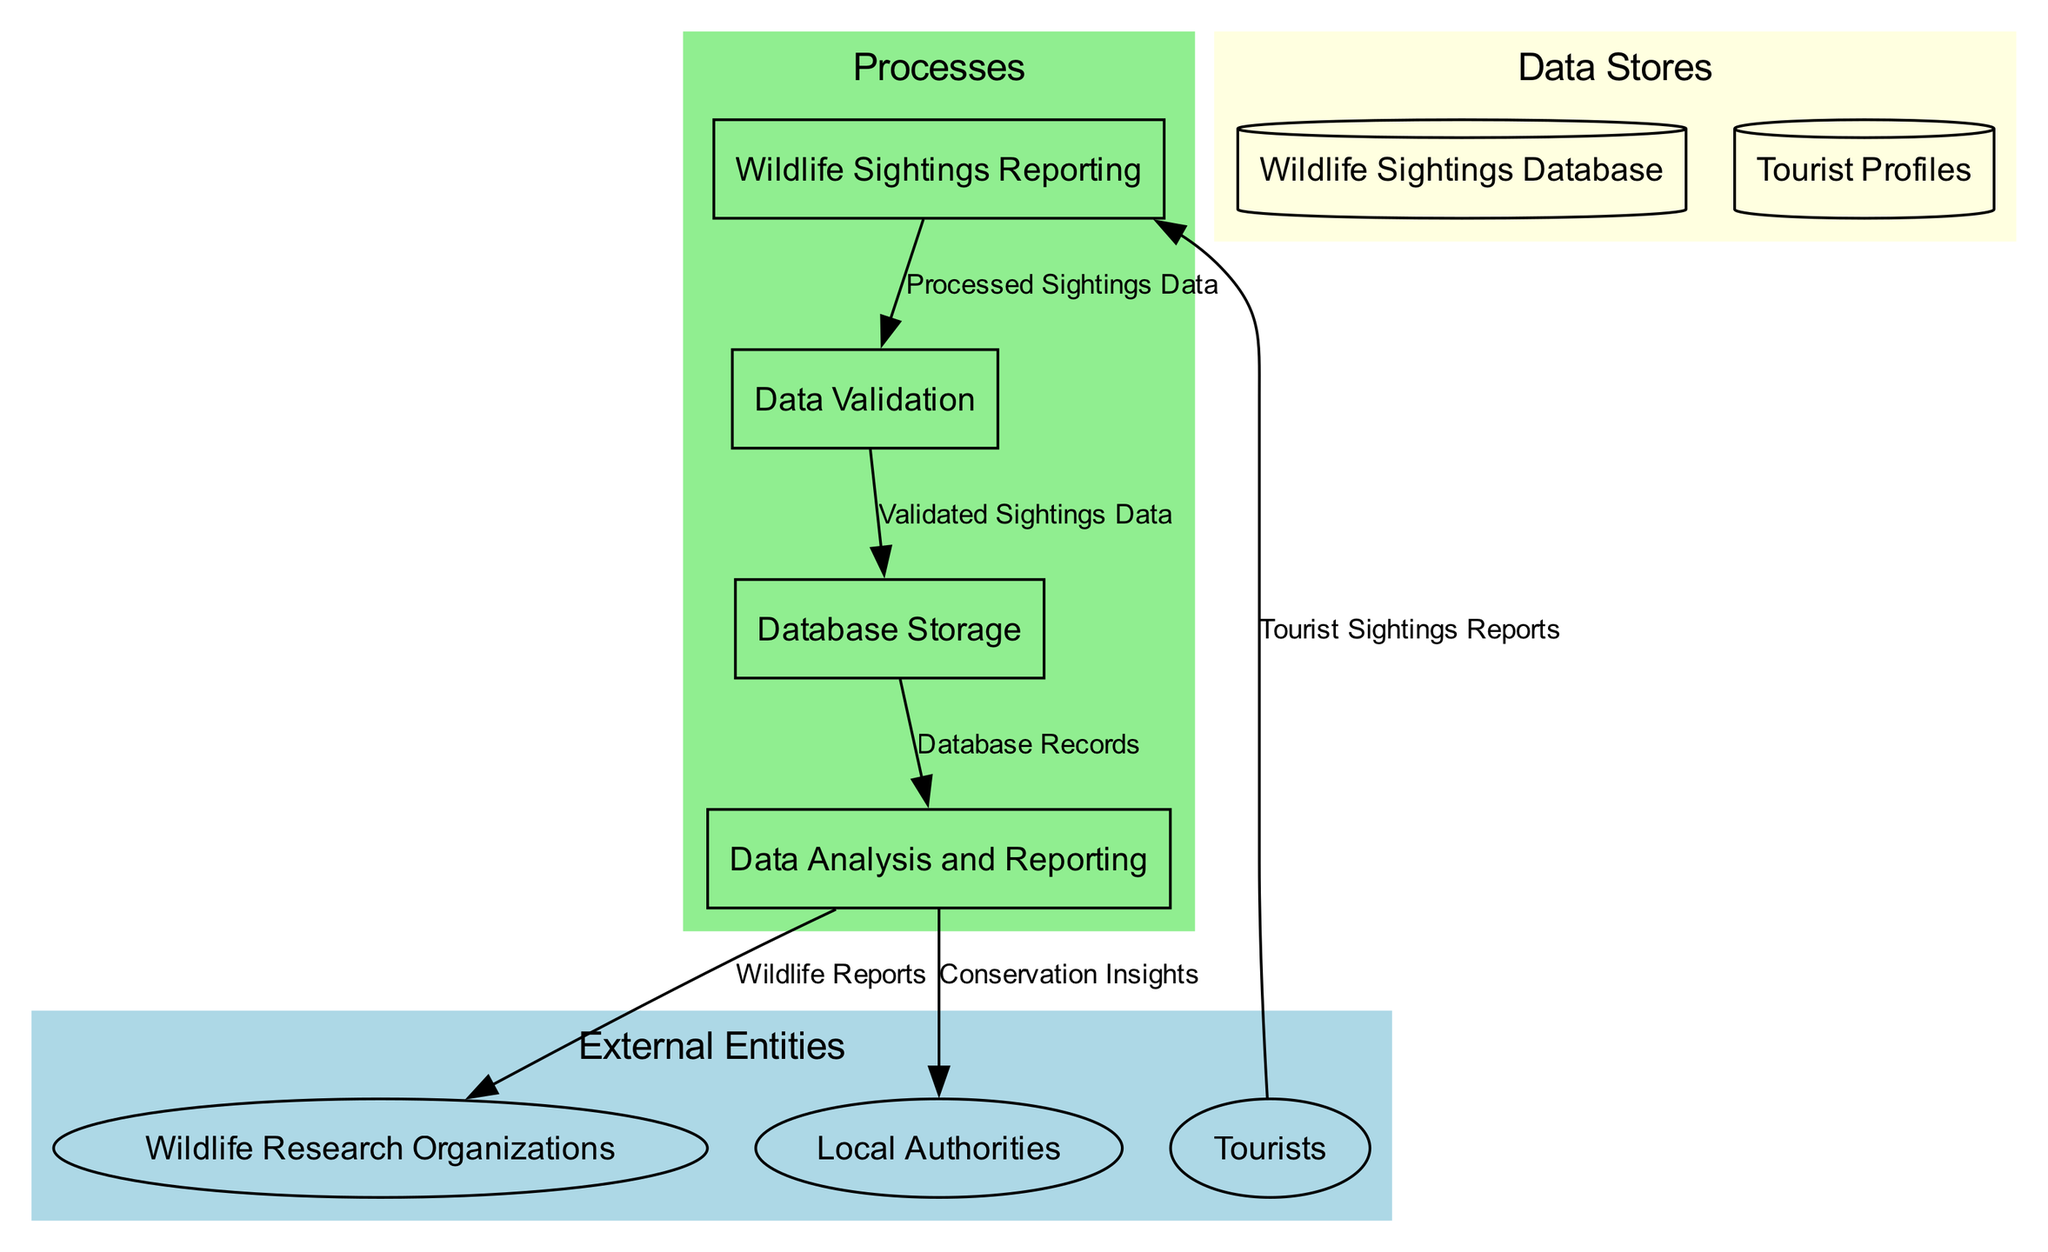What is the first process in the data flow? The first process identified in the diagram is "Wildlife Sightings Reporting," which is where tourists submit their wildlife observations during tours.
Answer: Wildlife Sightings Reporting How many external entities are represented in the diagram? The diagram contains three external entities: Tourists, Wildlife Research Organizations, and Local Authorities.
Answer: 3 What data is input into the Data Validation process? The Data Validation process receives "Processed Sightings Data" as input, which is the result of the Wildlife Sightings Reporting process.
Answer: Processed Sightings Data Which process outputs Wildlife Reports? The "Data Analysis and Reporting" process is responsible for outputting Wildlife Reports as one of its outputs.
Answer: Data Analysis and Reporting What is the final output received by Local Authorities? The final output received by Local Authorities is "Conservation Insights," which is generated from the Data Analysis and Reporting process.
Answer: Conservation Insights How many processes are in the diagram? The diagram features four processes: Wildlife Sightings Reporting, Data Validation, Database Storage, and Data Analysis and Reporting.
Answer: 4 What relationship exists between tourists and Wildlife Sightings Reporting? The relationship is that tourists provide "Tourist Sightings Reports," which are the input to the Wildlife Sightings Reporting process.
Answer: Provides input From which process is Validated Sightings Data output? Validated Sightings Data is the output of the "Data Validation" process, which follows the Wildlife Sightings Reporting process.
Answer: Data Validation What type of data store is the Wildlife Sightings Database? The Wildlife Sightings Database is classified as a "Central repository" where all validated sightings data are stored.
Answer: Central repository What do Wildlife Research Organizations receive as an output? Wildlife Research Organizations receive "Wildlife Reports" as an output from the Data Analysis and Reporting process.
Answer: Wildlife Reports 